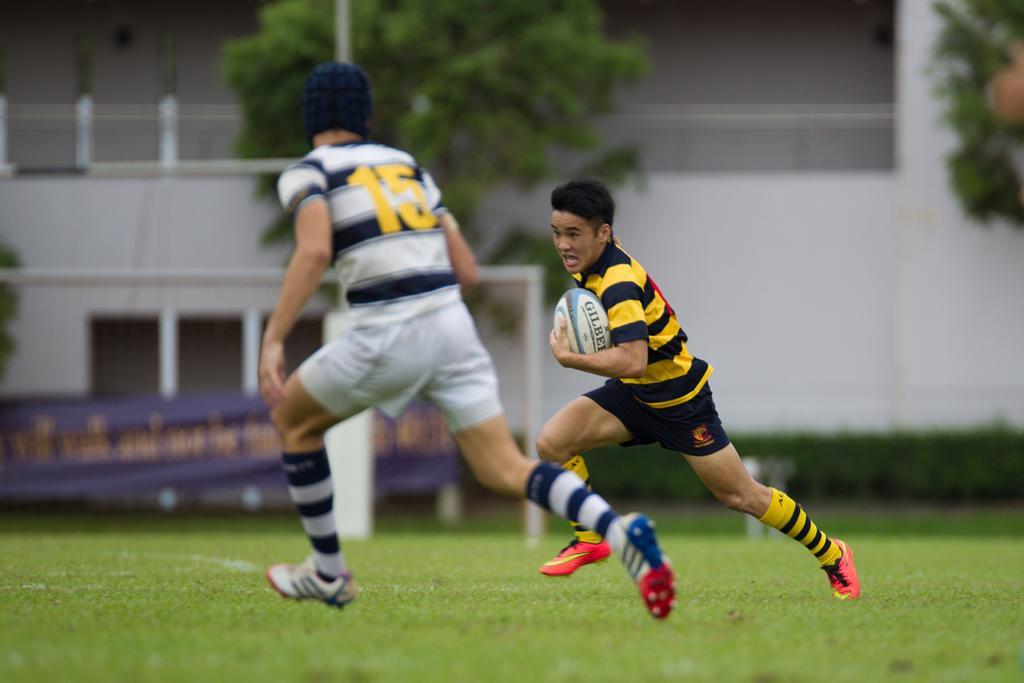Could you give a brief overview of what you see in this image? In this picture there are two boys in the ground, they are playing the game and there are some trees around the area of the image, the floor on which they are playing is grass floor. 